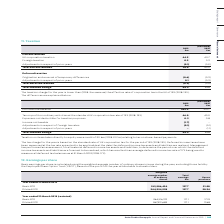According to Auto Trader's financial document, What was the Taxation on items taken directly to equity? a credit of £0.6m (2018: £0.1m) relating to tax on share-based payments. The document states: "Taxation on items taken directly to equity was a credit of £0.6m (2018: £0.1m) relating to tax on share-based payments...." Also, What was the effective rate of corporation tax in the UK? According to the financial document, 19%. The relevant text states: "ivities at the standard UK corporation tax rate of 19% (2018: 19%) 46.0 40.0..." Also, For which years was the total taxation charge calculated in? The document shows two values: 2019 and 2018. From the document: "Group plc Annual Report and Financial Statements 2019 | 105 (Restated) 2018 £m..." Additionally, In which year was Expenses not deductible for taxation purposes larger? According to the financial document, 2018. The relevant text states: "(Restated) 2018 £m..." Also, can you calculate: What was the change in Total taxation charge in 2019 from 2018? Based on the calculation: 44.5-39.6, the result is 4.9 (in millions). This is based on the information: "Total taxation charge 44.5 39.6 Total taxation charge 44.5 39.6..." The key data points involved are: 39.6, 44.5. Also, can you calculate: What was the percentage change in Total taxation charge in 2019 from 2018? To answer this question, I need to perform calculations using the financial data. The calculation is: (44.5-39.6)/39.6, which equals 12.37 (percentage). This is based on the information: "Total taxation charge 44.5 39.6 Total taxation charge 44.5 39.6..." The key data points involved are: 39.6, 44.5. 